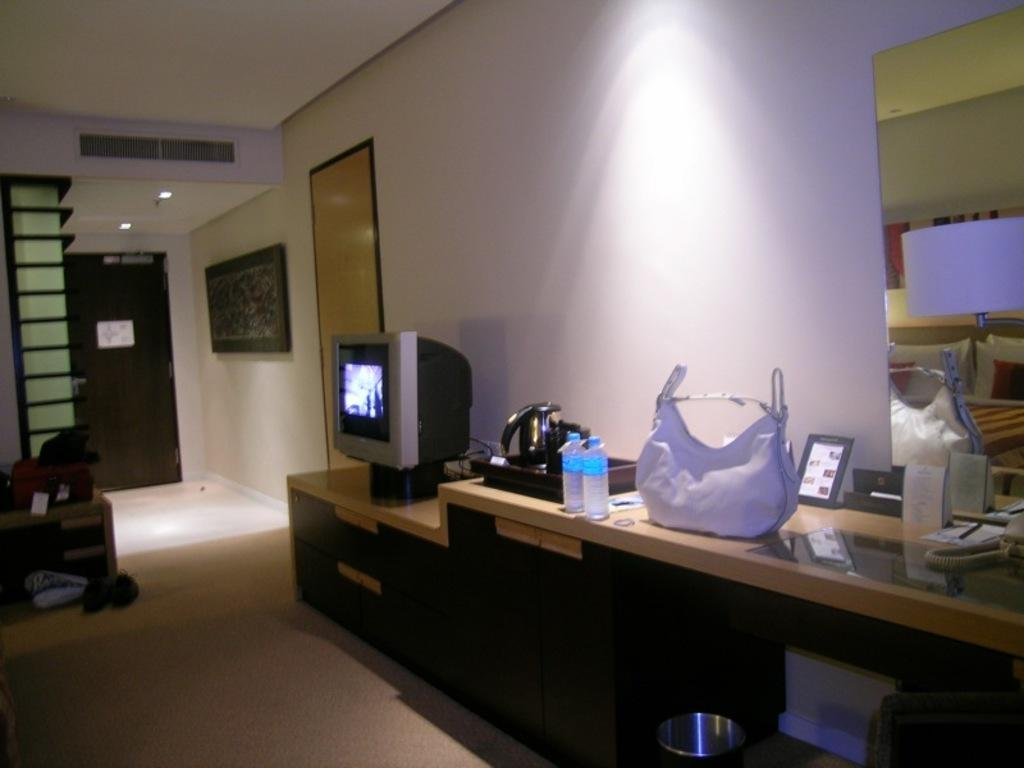What piece of furniture is in the room? There is a desk in the room. What object is on the desk? A mirror, a bag, bottles, and a television are on the desk. What is the purpose of the mirror on the desk? The mirror on the desk can be used for personal grooming or to check one's appearance. What can be seen on the left side of the room? There are shoes on the left side of the room. What type of shade is being used to protect the desk from sunlight? There is no mention of a shade in the image, and the desk is not being protected from sunlight. 